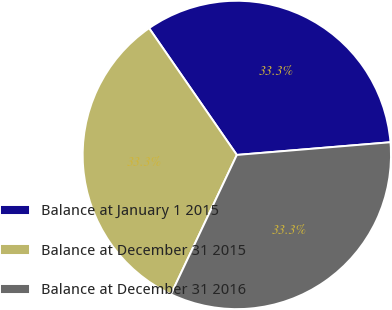Convert chart to OTSL. <chart><loc_0><loc_0><loc_500><loc_500><pie_chart><fcel>Balance at January 1 2015<fcel>Balance at December 31 2015<fcel>Balance at December 31 2016<nl><fcel>33.32%<fcel>33.33%<fcel>33.34%<nl></chart> 